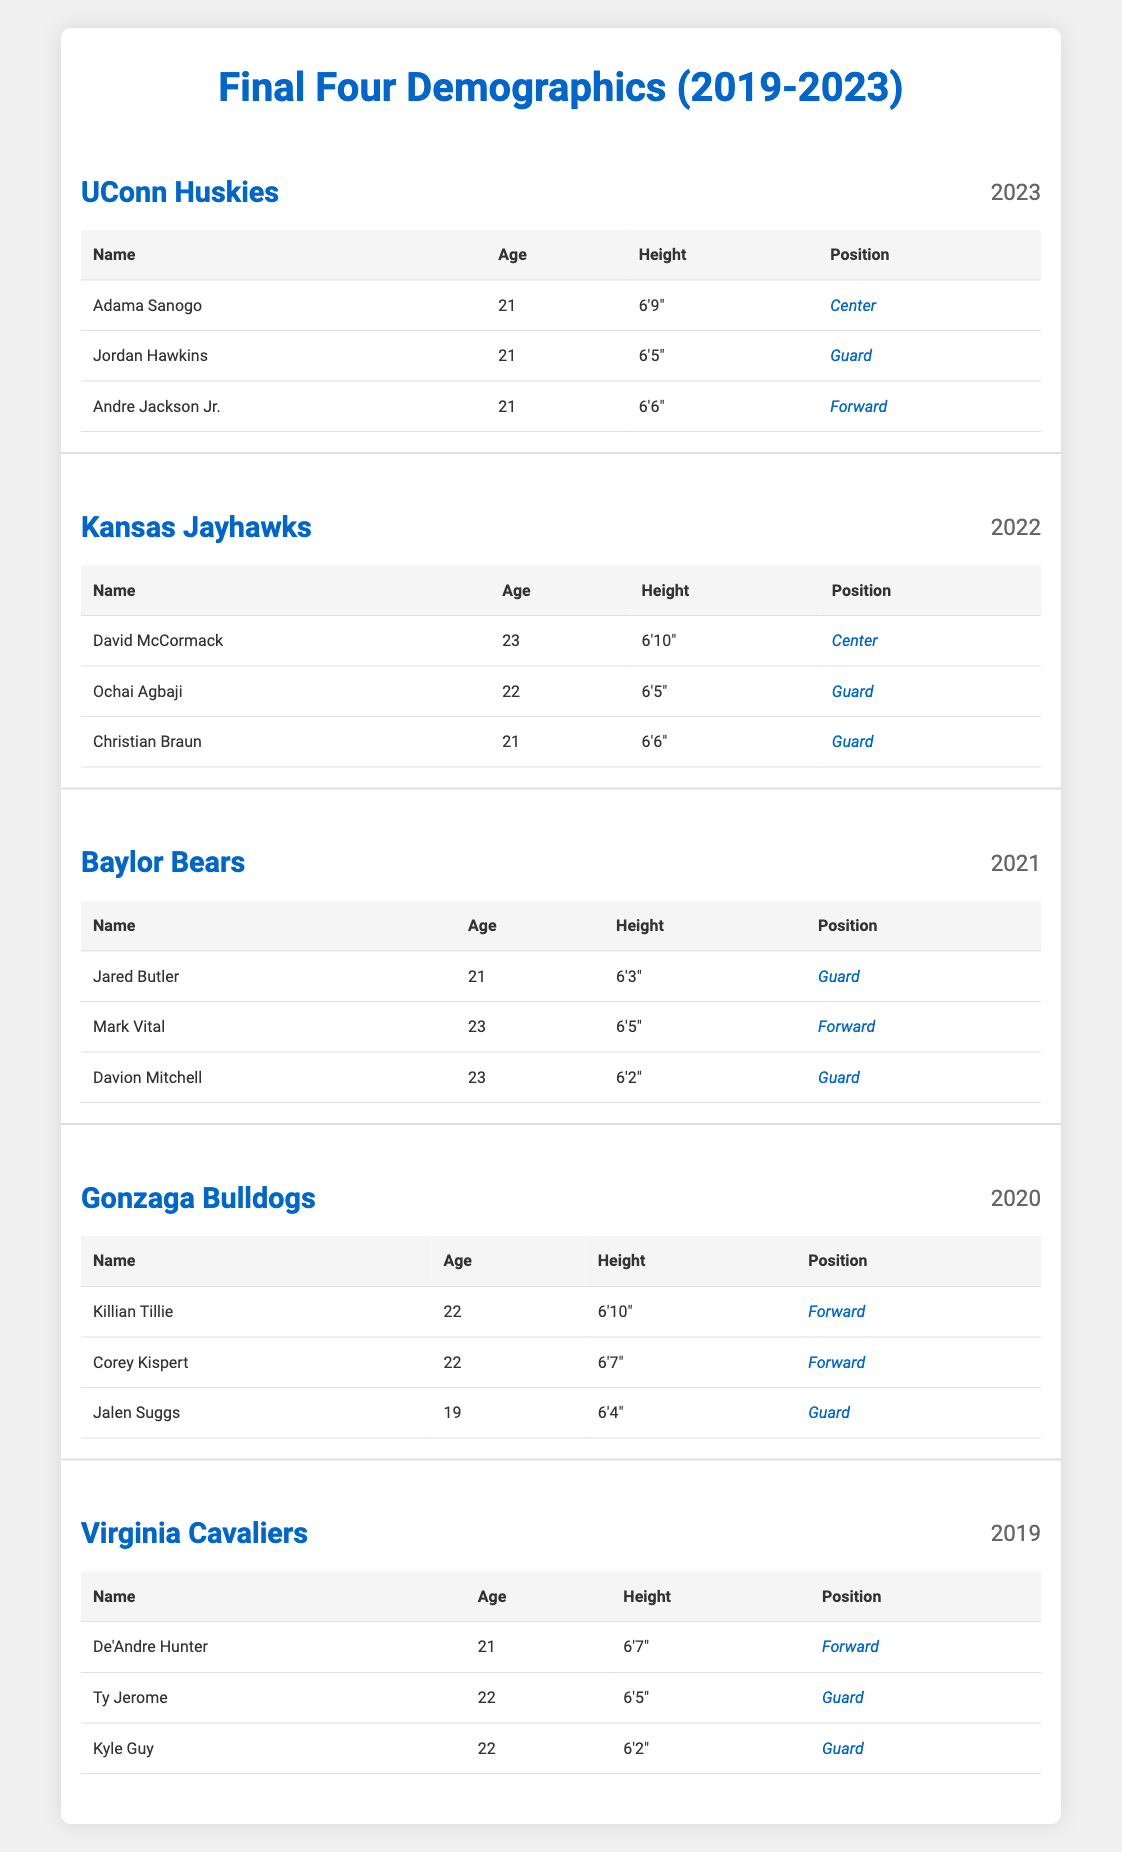What is the age of Adama Sanogo? The table lists Adama Sanogo under the UConn Huskies team for the year 2023, and his age is stated as 21.
Answer: 21 How tall is David McCormack? In the table for the Kansas Jayhawks in 2022, David McCormack's height is listed as 6'10".
Answer: 6'10" Which team had a player named Jalen Suggs? The table shows that Jalen Suggs was part of the Gonzaga Bulldogs team in the year 2020.
Answer: Gonzaga Bulldogs What is the average height of players in the 2023 Final Four? The heights of the UConn Huskies players are 6'9", 6'5", and 6'6". First convert these to inches: 81, 77, and 78. Then, sum them (81 + 77 + 78 = 236) and divide by the number of players (236 / 3 = 78.67). The average height is approximately 6'6.67".
Answer: 6'6.67" Was there a player in the Final Four between 2019 and 2023 who was younger than 19? Checking the table data, the youngest player is Jalen Suggs at 19 during the 2020 season. There is no player younger than him in the provided years.
Answer: No Which position appears most frequently in the player demographics for the Final Fours from 2019 to 2023? The positions listed are Center, Guard, and Forward. Counting each position: Guards appear 7 times, Forwards 5 times, and Centers 3 times. Therefore, Guards appear most frequently.
Answer: Guard What is the difference in age between the oldest and youngest players in the table? The oldest player is David McCormack at 23 years from 2022, while the youngest is Jalen Suggs at 19 years from 2020. The difference is 23 - 19 = 4 years.
Answer: 4 years How many players from the Virginia Cavaliers are listed as Guards? The Virginia Cavaliers have 3 players: Ty Jerome and Kyle Guy are both Guards, making a total of 2 Guards on the roster for 2019.
Answer: 2 